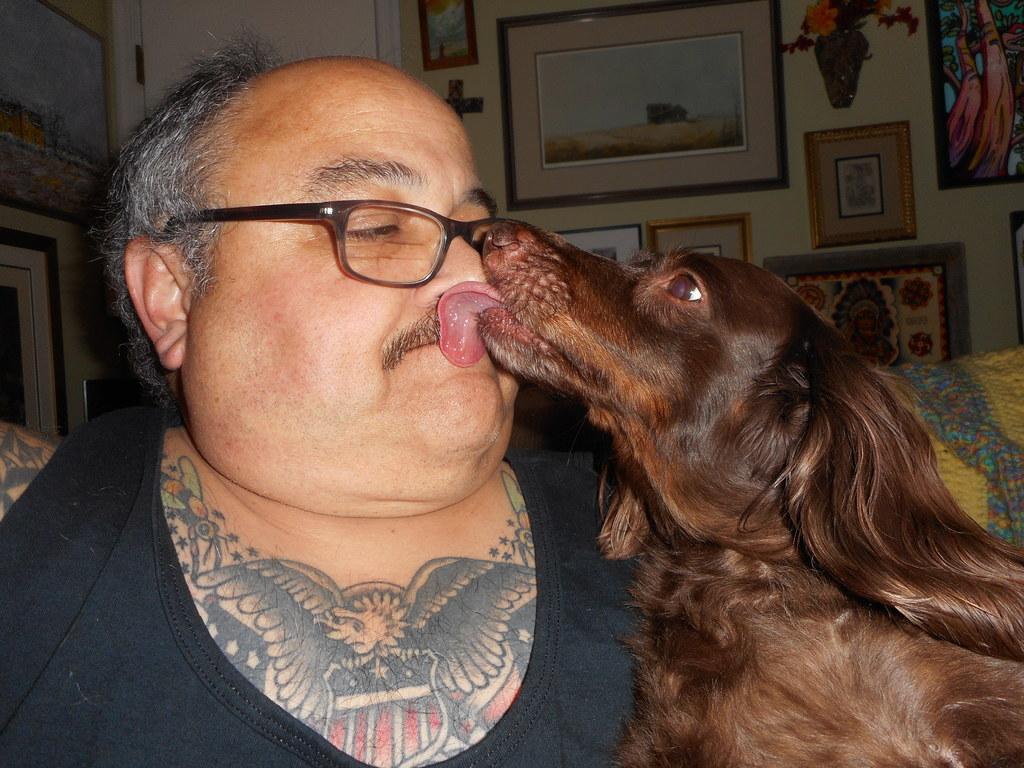What is located on the left side of the image? There is a man on the left side of the image. What is on the right side of the image? There is a dog on the right side of the image. What can be seen in the background of the image? There are photo frames in the background of the image. How are the photo frames positioned in the image? The photo frames are fixed to a wall. What type of voice can be heard coming from the dog in the image? Dogs do not have the ability to produce human-like voices, so there is no voice coming from the dog in the image. 